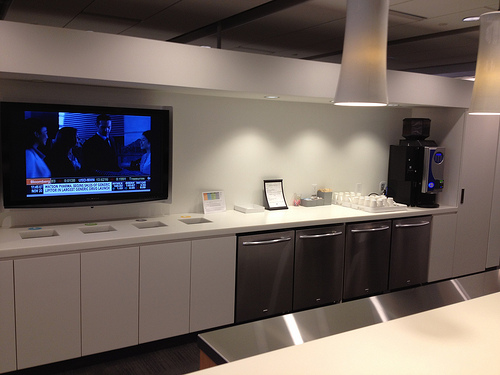What objects can be found on the counter besides the coffee dispenser? Besides the coffee dispenser, the counter holds several white cups arranged neatly, a small frame or sign, and a few paper napkins, adding to the orderly and functional setup. Imagine a future tech advancement integrated into this room. In the future, this room might feature an AI-powered coffee dispenser that not only remembers individual preferences but also adjusts the ingredients based on health data retrieved from personal wearable devices. The television could be replaced with an interactive digital wall display, featuring smart glass technology, allowing team members to participate in virtual meetings, collaborate on projects in a virtual workspace, or even indulge in augmented reality entertainment during breaks. Voice-activated lights and appliances might add to the room’s smart capabilities, creating an even more seamless and efficient environment. Imagine a scenario where this room is transformed into a relaxation lounge. In a transformed relaxation lounge, fluffy couches replace the counters. The coffee dispenser remains, but an array of herbal teas and ambient music play softly in the background. The once bright overhead lights dim to a softer glow. Plants and greenery add tranquility, and a bookshelf filled with an array of genres encourages a much-needed mental break. Employees can be seen sipping their favorite beverages, engrossed in good books, or simply enjoying the serene environment to recharge for their next work session. 